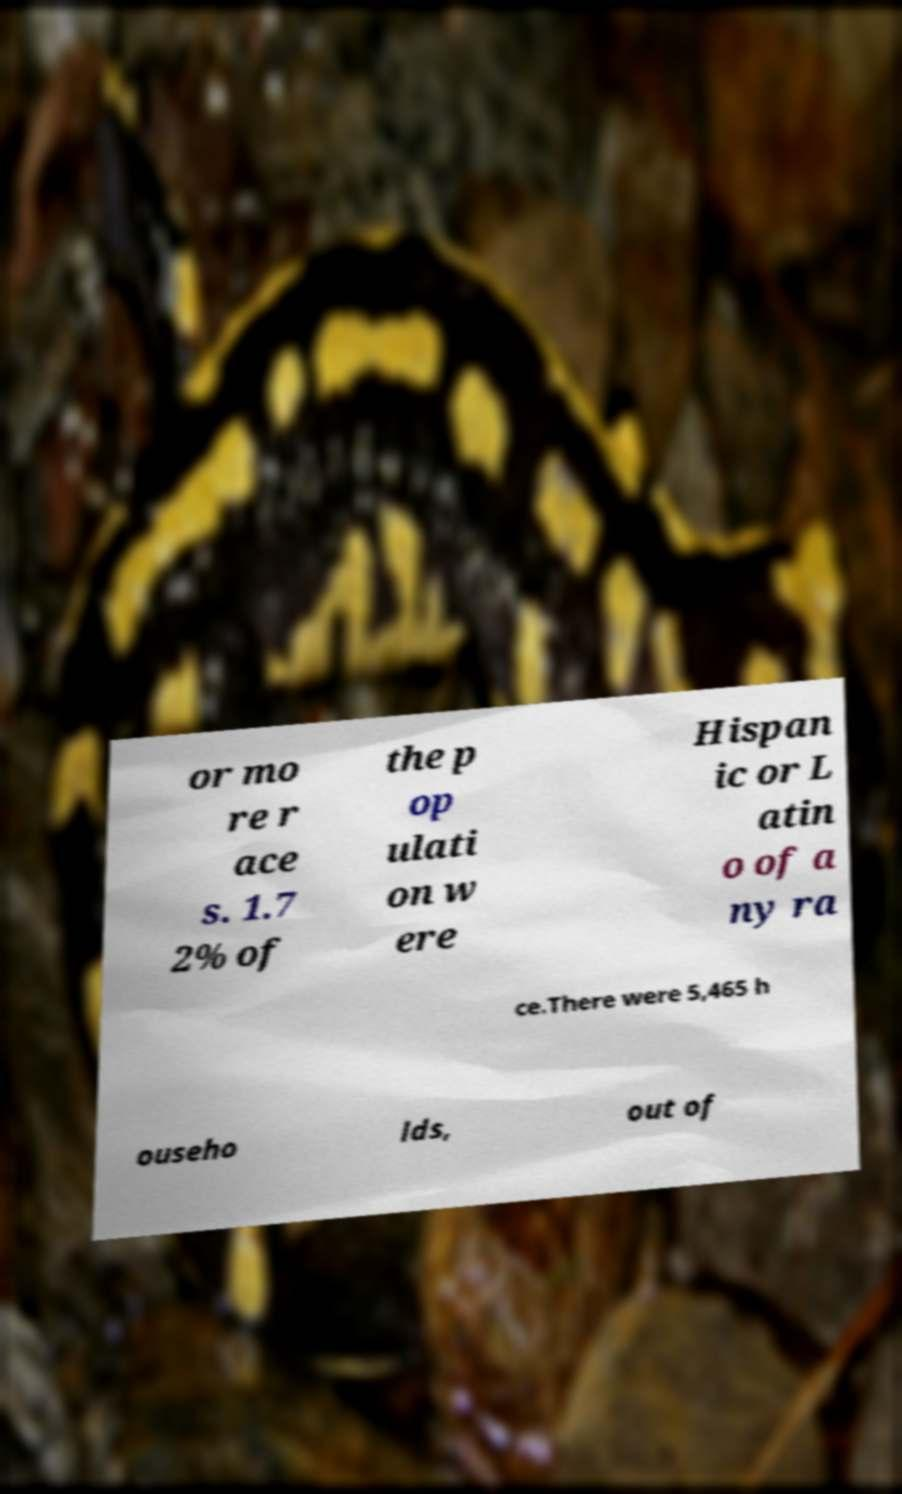Could you extract and type out the text from this image? or mo re r ace s. 1.7 2% of the p op ulati on w ere Hispan ic or L atin o of a ny ra ce.There were 5,465 h ouseho lds, out of 